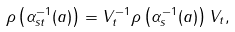Convert formula to latex. <formula><loc_0><loc_0><loc_500><loc_500>\rho \left ( \alpha _ { s t } ^ { - 1 } ( a ) \right ) = V _ { t } ^ { - 1 } \rho \left ( \alpha _ { s } ^ { - 1 } ( a ) \right ) V _ { t } ,</formula> 